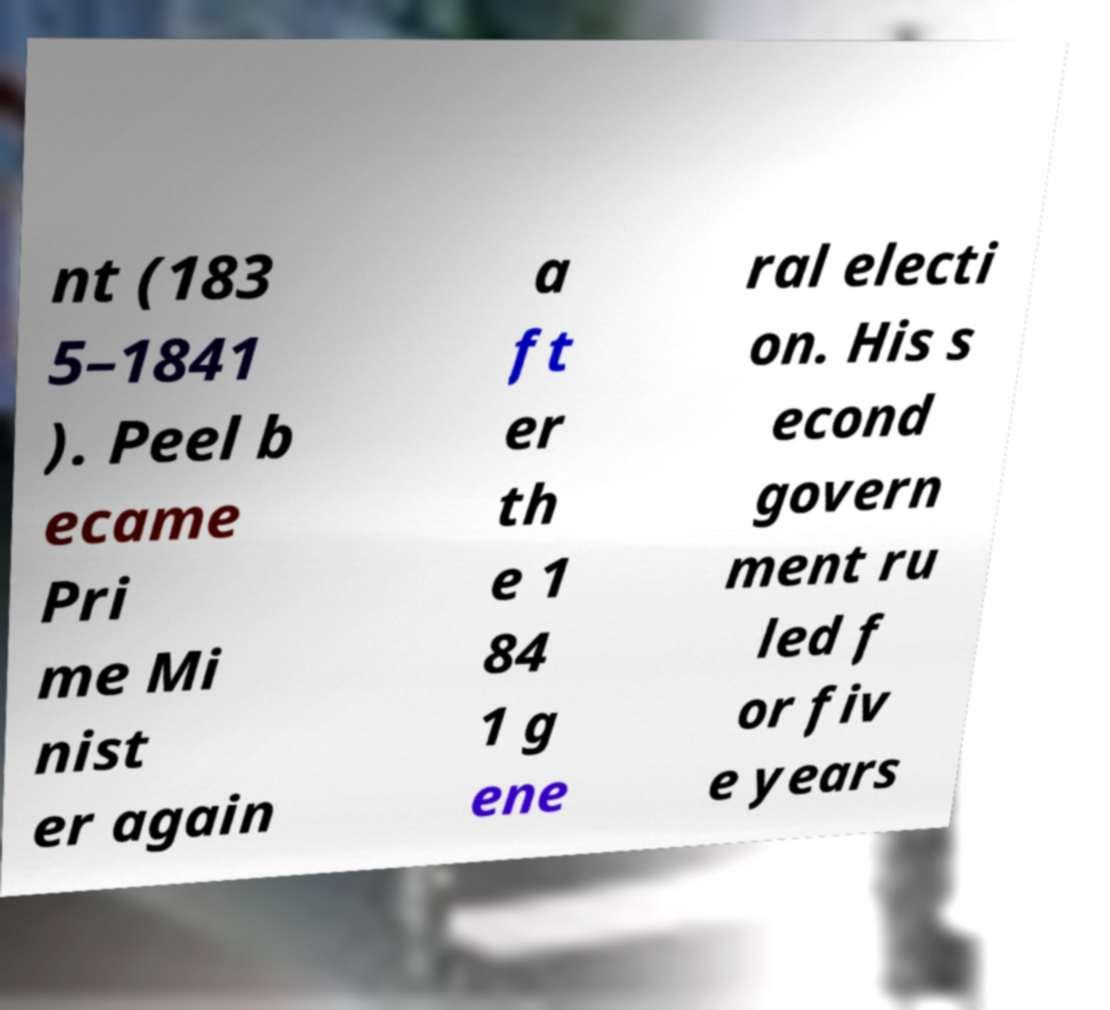Can you accurately transcribe the text from the provided image for me? nt (183 5–1841 ). Peel b ecame Pri me Mi nist er again a ft er th e 1 84 1 g ene ral electi on. His s econd govern ment ru led f or fiv e years 